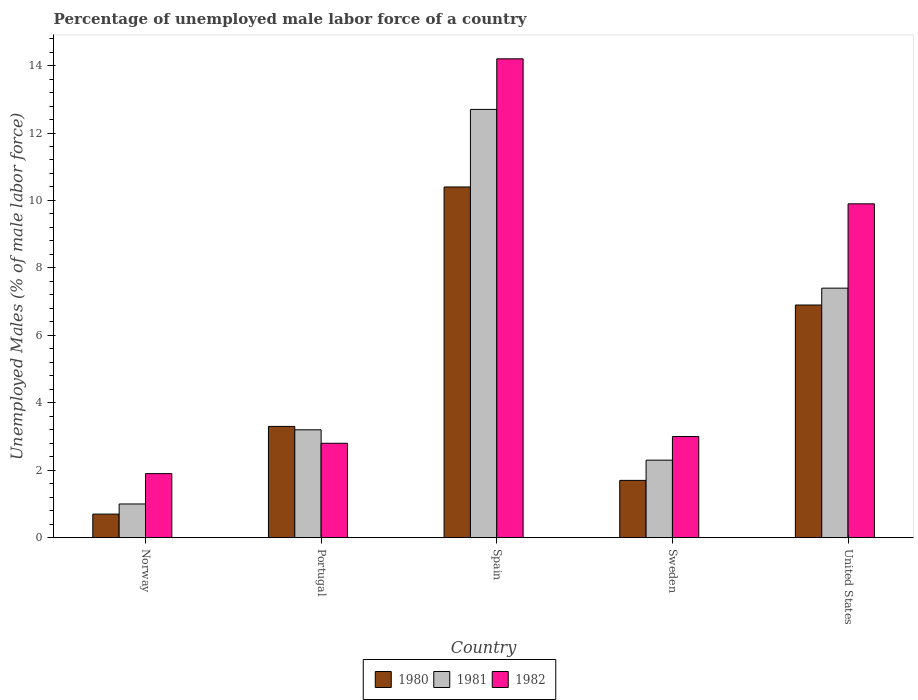How many different coloured bars are there?
Offer a terse response. 3. How many groups of bars are there?
Offer a terse response. 5. Are the number of bars per tick equal to the number of legend labels?
Your answer should be compact. Yes. How many bars are there on the 1st tick from the left?
Provide a short and direct response. 3. What is the label of the 1st group of bars from the left?
Ensure brevity in your answer.  Norway. What is the percentage of unemployed male labor force in 1980 in Spain?
Keep it short and to the point. 10.4. Across all countries, what is the maximum percentage of unemployed male labor force in 1982?
Your answer should be compact. 14.2. Across all countries, what is the minimum percentage of unemployed male labor force in 1982?
Provide a succinct answer. 1.9. In which country was the percentage of unemployed male labor force in 1981 minimum?
Your response must be concise. Norway. What is the total percentage of unemployed male labor force in 1981 in the graph?
Provide a succinct answer. 26.6. What is the difference between the percentage of unemployed male labor force in 1981 in Spain and that in Sweden?
Give a very brief answer. 10.4. What is the difference between the percentage of unemployed male labor force in 1982 in Sweden and the percentage of unemployed male labor force in 1981 in United States?
Your answer should be very brief. -4.4. What is the average percentage of unemployed male labor force in 1981 per country?
Keep it short and to the point. 5.32. What is the difference between the percentage of unemployed male labor force of/in 1982 and percentage of unemployed male labor force of/in 1980 in United States?
Keep it short and to the point. 3. What is the ratio of the percentage of unemployed male labor force in 1981 in Portugal to that in Spain?
Offer a very short reply. 0.25. Is the percentage of unemployed male labor force in 1982 in Norway less than that in United States?
Ensure brevity in your answer.  Yes. What is the difference between the highest and the second highest percentage of unemployed male labor force in 1982?
Your answer should be very brief. 6.9. What is the difference between the highest and the lowest percentage of unemployed male labor force in 1982?
Your answer should be very brief. 12.3. Are all the bars in the graph horizontal?
Make the answer very short. No. What is the difference between two consecutive major ticks on the Y-axis?
Provide a short and direct response. 2. Does the graph contain any zero values?
Your response must be concise. No. How many legend labels are there?
Your answer should be very brief. 3. How are the legend labels stacked?
Offer a terse response. Horizontal. What is the title of the graph?
Keep it short and to the point. Percentage of unemployed male labor force of a country. Does "2006" appear as one of the legend labels in the graph?
Ensure brevity in your answer.  No. What is the label or title of the Y-axis?
Keep it short and to the point. Unemployed Males (% of male labor force). What is the Unemployed Males (% of male labor force) in 1980 in Norway?
Ensure brevity in your answer.  0.7. What is the Unemployed Males (% of male labor force) of 1982 in Norway?
Your answer should be compact. 1.9. What is the Unemployed Males (% of male labor force) of 1980 in Portugal?
Your answer should be very brief. 3.3. What is the Unemployed Males (% of male labor force) in 1981 in Portugal?
Give a very brief answer. 3.2. What is the Unemployed Males (% of male labor force) of 1982 in Portugal?
Offer a terse response. 2.8. What is the Unemployed Males (% of male labor force) in 1980 in Spain?
Make the answer very short. 10.4. What is the Unemployed Males (% of male labor force) of 1981 in Spain?
Ensure brevity in your answer.  12.7. What is the Unemployed Males (% of male labor force) of 1982 in Spain?
Provide a succinct answer. 14.2. What is the Unemployed Males (% of male labor force) of 1980 in Sweden?
Provide a short and direct response. 1.7. What is the Unemployed Males (% of male labor force) of 1981 in Sweden?
Provide a succinct answer. 2.3. What is the Unemployed Males (% of male labor force) in 1980 in United States?
Your answer should be compact. 6.9. What is the Unemployed Males (% of male labor force) of 1981 in United States?
Offer a terse response. 7.4. What is the Unemployed Males (% of male labor force) of 1982 in United States?
Offer a terse response. 9.9. Across all countries, what is the maximum Unemployed Males (% of male labor force) in 1980?
Ensure brevity in your answer.  10.4. Across all countries, what is the maximum Unemployed Males (% of male labor force) of 1981?
Make the answer very short. 12.7. Across all countries, what is the maximum Unemployed Males (% of male labor force) of 1982?
Provide a short and direct response. 14.2. Across all countries, what is the minimum Unemployed Males (% of male labor force) of 1980?
Give a very brief answer. 0.7. Across all countries, what is the minimum Unemployed Males (% of male labor force) of 1981?
Your answer should be compact. 1. Across all countries, what is the minimum Unemployed Males (% of male labor force) of 1982?
Provide a short and direct response. 1.9. What is the total Unemployed Males (% of male labor force) of 1981 in the graph?
Offer a terse response. 26.6. What is the total Unemployed Males (% of male labor force) of 1982 in the graph?
Your answer should be compact. 31.8. What is the difference between the Unemployed Males (% of male labor force) in 1980 in Norway and that in Portugal?
Your answer should be very brief. -2.6. What is the difference between the Unemployed Males (% of male labor force) of 1981 in Norway and that in Portugal?
Give a very brief answer. -2.2. What is the difference between the Unemployed Males (% of male labor force) in 1982 in Norway and that in Spain?
Provide a succinct answer. -12.3. What is the difference between the Unemployed Males (% of male labor force) of 1982 in Norway and that in Sweden?
Offer a terse response. -1.1. What is the difference between the Unemployed Males (% of male labor force) of 1981 in Norway and that in United States?
Offer a terse response. -6.4. What is the difference between the Unemployed Males (% of male labor force) in 1982 in Norway and that in United States?
Your answer should be very brief. -8. What is the difference between the Unemployed Males (% of male labor force) in 1980 in Portugal and that in Spain?
Your answer should be very brief. -7.1. What is the difference between the Unemployed Males (% of male labor force) in 1980 in Portugal and that in Sweden?
Provide a succinct answer. 1.6. What is the difference between the Unemployed Males (% of male labor force) in 1982 in Portugal and that in Sweden?
Provide a short and direct response. -0.2. What is the difference between the Unemployed Males (% of male labor force) of 1980 in Portugal and that in United States?
Provide a succinct answer. -3.6. What is the difference between the Unemployed Males (% of male labor force) in 1981 in Portugal and that in United States?
Keep it short and to the point. -4.2. What is the difference between the Unemployed Males (% of male labor force) in 1980 in Spain and that in Sweden?
Offer a terse response. 8.7. What is the difference between the Unemployed Males (% of male labor force) in 1981 in Spain and that in Sweden?
Your answer should be compact. 10.4. What is the difference between the Unemployed Males (% of male labor force) in 1980 in Sweden and that in United States?
Provide a short and direct response. -5.2. What is the difference between the Unemployed Males (% of male labor force) in 1981 in Sweden and that in United States?
Offer a very short reply. -5.1. What is the difference between the Unemployed Males (% of male labor force) of 1982 in Sweden and that in United States?
Offer a terse response. -6.9. What is the difference between the Unemployed Males (% of male labor force) of 1980 in Norway and the Unemployed Males (% of male labor force) of 1982 in Portugal?
Provide a succinct answer. -2.1. What is the difference between the Unemployed Males (% of male labor force) in 1980 in Norway and the Unemployed Males (% of male labor force) in 1981 in Spain?
Your answer should be very brief. -12. What is the difference between the Unemployed Males (% of male labor force) of 1981 in Norway and the Unemployed Males (% of male labor force) of 1982 in Spain?
Offer a terse response. -13.2. What is the difference between the Unemployed Males (% of male labor force) in 1980 in Norway and the Unemployed Males (% of male labor force) in 1982 in Sweden?
Offer a terse response. -2.3. What is the difference between the Unemployed Males (% of male labor force) of 1981 in Norway and the Unemployed Males (% of male labor force) of 1982 in United States?
Keep it short and to the point. -8.9. What is the difference between the Unemployed Males (% of male labor force) in 1980 in Portugal and the Unemployed Males (% of male labor force) in 1981 in Spain?
Offer a very short reply. -9.4. What is the difference between the Unemployed Males (% of male labor force) of 1981 in Portugal and the Unemployed Males (% of male labor force) of 1982 in Sweden?
Provide a succinct answer. 0.2. What is the difference between the Unemployed Males (% of male labor force) in 1980 in Portugal and the Unemployed Males (% of male labor force) in 1981 in United States?
Your answer should be compact. -4.1. What is the difference between the Unemployed Males (% of male labor force) of 1981 in Portugal and the Unemployed Males (% of male labor force) of 1982 in United States?
Keep it short and to the point. -6.7. What is the difference between the Unemployed Males (% of male labor force) of 1980 in Spain and the Unemployed Males (% of male labor force) of 1981 in United States?
Your response must be concise. 3. What is the difference between the Unemployed Males (% of male labor force) in 1980 in Spain and the Unemployed Males (% of male labor force) in 1982 in United States?
Your answer should be very brief. 0.5. What is the difference between the Unemployed Males (% of male labor force) in 1981 in Spain and the Unemployed Males (% of male labor force) in 1982 in United States?
Your response must be concise. 2.8. What is the difference between the Unemployed Males (% of male labor force) of 1980 in Sweden and the Unemployed Males (% of male labor force) of 1981 in United States?
Your answer should be very brief. -5.7. What is the difference between the Unemployed Males (% of male labor force) in 1981 in Sweden and the Unemployed Males (% of male labor force) in 1982 in United States?
Give a very brief answer. -7.6. What is the average Unemployed Males (% of male labor force) of 1980 per country?
Give a very brief answer. 4.6. What is the average Unemployed Males (% of male labor force) in 1981 per country?
Make the answer very short. 5.32. What is the average Unemployed Males (% of male labor force) in 1982 per country?
Make the answer very short. 6.36. What is the difference between the Unemployed Males (% of male labor force) of 1980 and Unemployed Males (% of male labor force) of 1981 in Norway?
Ensure brevity in your answer.  -0.3. What is the difference between the Unemployed Males (% of male labor force) in 1980 and Unemployed Males (% of male labor force) in 1982 in Norway?
Your answer should be compact. -1.2. What is the difference between the Unemployed Males (% of male labor force) of 1980 and Unemployed Males (% of male labor force) of 1982 in Portugal?
Your answer should be compact. 0.5. What is the difference between the Unemployed Males (% of male labor force) of 1981 and Unemployed Males (% of male labor force) of 1982 in Portugal?
Make the answer very short. 0.4. What is the difference between the Unemployed Males (% of male labor force) of 1980 and Unemployed Males (% of male labor force) of 1981 in Spain?
Make the answer very short. -2.3. What is the difference between the Unemployed Males (% of male labor force) of 1981 and Unemployed Males (% of male labor force) of 1982 in Spain?
Keep it short and to the point. -1.5. What is the difference between the Unemployed Males (% of male labor force) of 1980 and Unemployed Males (% of male labor force) of 1982 in Sweden?
Your response must be concise. -1.3. What is the ratio of the Unemployed Males (% of male labor force) of 1980 in Norway to that in Portugal?
Keep it short and to the point. 0.21. What is the ratio of the Unemployed Males (% of male labor force) of 1981 in Norway to that in Portugal?
Offer a very short reply. 0.31. What is the ratio of the Unemployed Males (% of male labor force) of 1982 in Norway to that in Portugal?
Give a very brief answer. 0.68. What is the ratio of the Unemployed Males (% of male labor force) of 1980 in Norway to that in Spain?
Your response must be concise. 0.07. What is the ratio of the Unemployed Males (% of male labor force) in 1981 in Norway to that in Spain?
Your answer should be very brief. 0.08. What is the ratio of the Unemployed Males (% of male labor force) of 1982 in Norway to that in Spain?
Your response must be concise. 0.13. What is the ratio of the Unemployed Males (% of male labor force) of 1980 in Norway to that in Sweden?
Provide a succinct answer. 0.41. What is the ratio of the Unemployed Males (% of male labor force) of 1981 in Norway to that in Sweden?
Offer a very short reply. 0.43. What is the ratio of the Unemployed Males (% of male labor force) of 1982 in Norway to that in Sweden?
Offer a very short reply. 0.63. What is the ratio of the Unemployed Males (% of male labor force) in 1980 in Norway to that in United States?
Keep it short and to the point. 0.1. What is the ratio of the Unemployed Males (% of male labor force) in 1981 in Norway to that in United States?
Your response must be concise. 0.14. What is the ratio of the Unemployed Males (% of male labor force) of 1982 in Norway to that in United States?
Give a very brief answer. 0.19. What is the ratio of the Unemployed Males (% of male labor force) in 1980 in Portugal to that in Spain?
Offer a very short reply. 0.32. What is the ratio of the Unemployed Males (% of male labor force) in 1981 in Portugal to that in Spain?
Give a very brief answer. 0.25. What is the ratio of the Unemployed Males (% of male labor force) in 1982 in Portugal to that in Spain?
Make the answer very short. 0.2. What is the ratio of the Unemployed Males (% of male labor force) in 1980 in Portugal to that in Sweden?
Keep it short and to the point. 1.94. What is the ratio of the Unemployed Males (% of male labor force) in 1981 in Portugal to that in Sweden?
Make the answer very short. 1.39. What is the ratio of the Unemployed Males (% of male labor force) of 1980 in Portugal to that in United States?
Offer a terse response. 0.48. What is the ratio of the Unemployed Males (% of male labor force) of 1981 in Portugal to that in United States?
Ensure brevity in your answer.  0.43. What is the ratio of the Unemployed Males (% of male labor force) in 1982 in Portugal to that in United States?
Offer a terse response. 0.28. What is the ratio of the Unemployed Males (% of male labor force) in 1980 in Spain to that in Sweden?
Keep it short and to the point. 6.12. What is the ratio of the Unemployed Males (% of male labor force) in 1981 in Spain to that in Sweden?
Provide a succinct answer. 5.52. What is the ratio of the Unemployed Males (% of male labor force) in 1982 in Spain to that in Sweden?
Provide a succinct answer. 4.73. What is the ratio of the Unemployed Males (% of male labor force) of 1980 in Spain to that in United States?
Your answer should be compact. 1.51. What is the ratio of the Unemployed Males (% of male labor force) of 1981 in Spain to that in United States?
Provide a short and direct response. 1.72. What is the ratio of the Unemployed Males (% of male labor force) of 1982 in Spain to that in United States?
Offer a very short reply. 1.43. What is the ratio of the Unemployed Males (% of male labor force) of 1980 in Sweden to that in United States?
Offer a very short reply. 0.25. What is the ratio of the Unemployed Males (% of male labor force) of 1981 in Sweden to that in United States?
Your answer should be compact. 0.31. What is the ratio of the Unemployed Males (% of male labor force) in 1982 in Sweden to that in United States?
Offer a very short reply. 0.3. What is the difference between the highest and the second highest Unemployed Males (% of male labor force) of 1980?
Your answer should be compact. 3.5. What is the difference between the highest and the second highest Unemployed Males (% of male labor force) in 1981?
Give a very brief answer. 5.3. What is the difference between the highest and the second highest Unemployed Males (% of male labor force) of 1982?
Your answer should be compact. 4.3. What is the difference between the highest and the lowest Unemployed Males (% of male labor force) in 1980?
Your answer should be very brief. 9.7. 